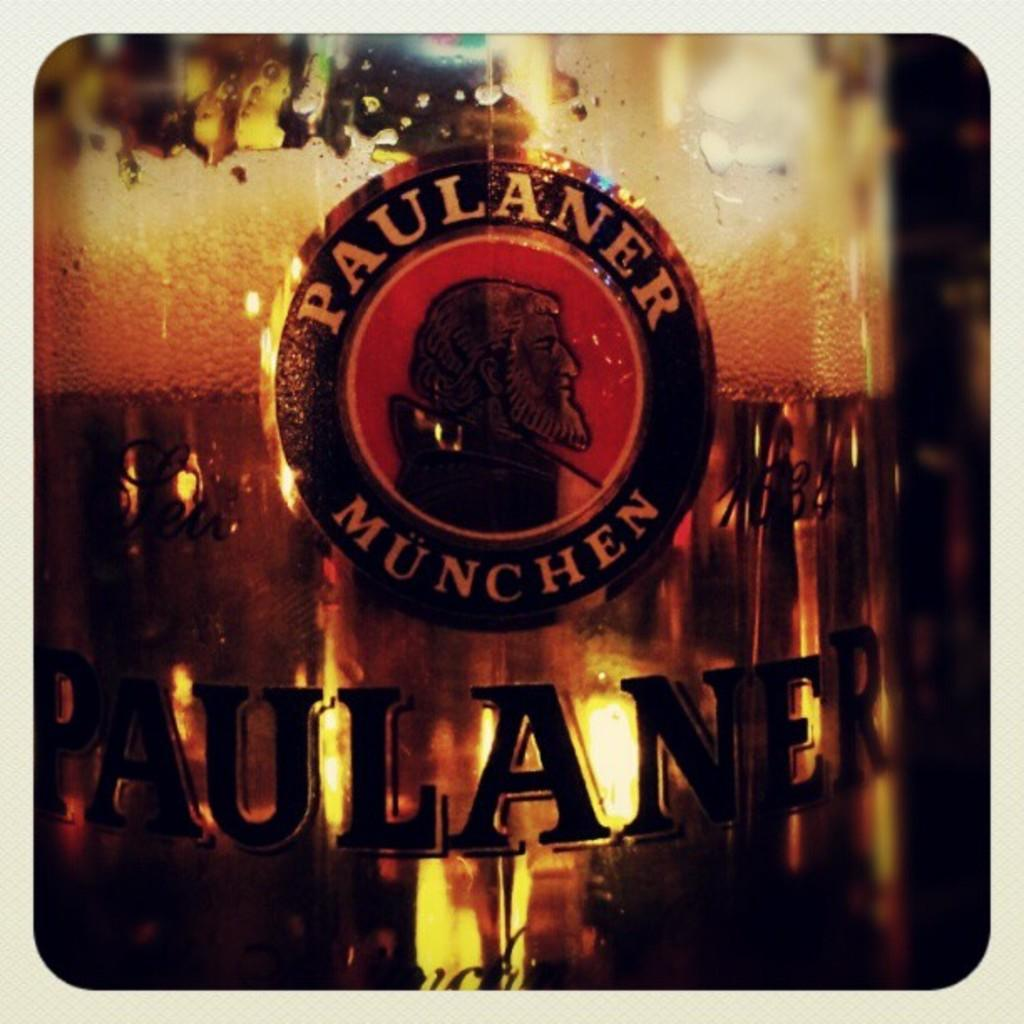<image>
Share a concise interpretation of the image provided. Bottle of Paulaner Munchen showing a man with a white beard on the label. 